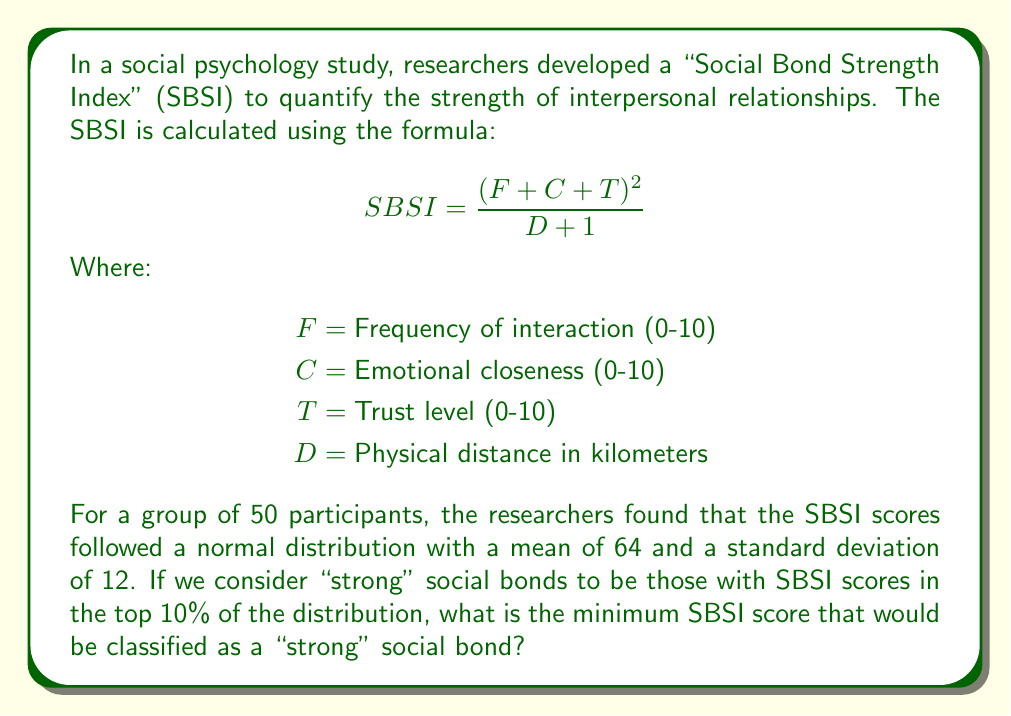Help me with this question. To solve this problem, we need to use the properties of the normal distribution and the concept of z-scores. Let's approach this step-by-step:

1) We're looking for the SBSI score that represents the 90th percentile of the distribution (top 10%).

2) In a normal distribution, we can find percentiles using z-scores. The z-score for the 90th percentile is approximately 1.28 (this is a standard value in normal distribution tables).

3) The formula for calculating a z-score is:

   $$ z = \frac{X - \mu}{\sigma} $$

   Where X is the score we're looking for, μ is the mean, and σ is the standard deviation.

4) We know that z = 1.28, μ = 64, and σ = 12. Let's substitute these into the formula:

   $$ 1.28 = \frac{X - 64}{12} $$

5) Now, let's solve for X:

   $$ 12 * 1.28 = X - 64 $$
   $$ 15.36 = X - 64 $$
   $$ X = 79.36 $$

6) Therefore, any SBSI score of 79.36 or higher would be in the top 10% of the distribution.

7) Since SBSI scores are likely to be rounded to whole numbers in practice, we would round this up to 80.
Answer: 80 